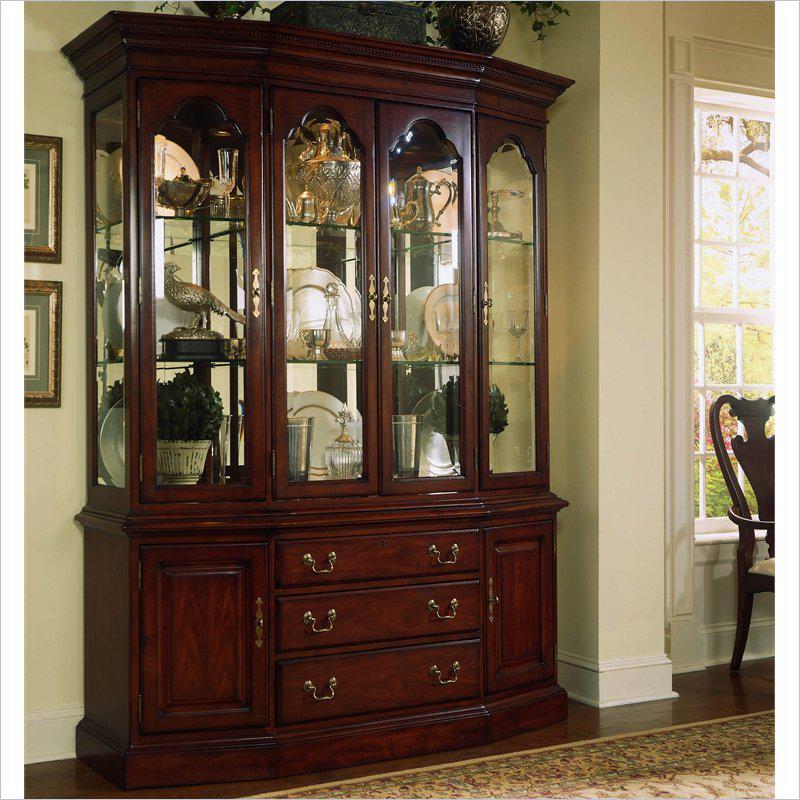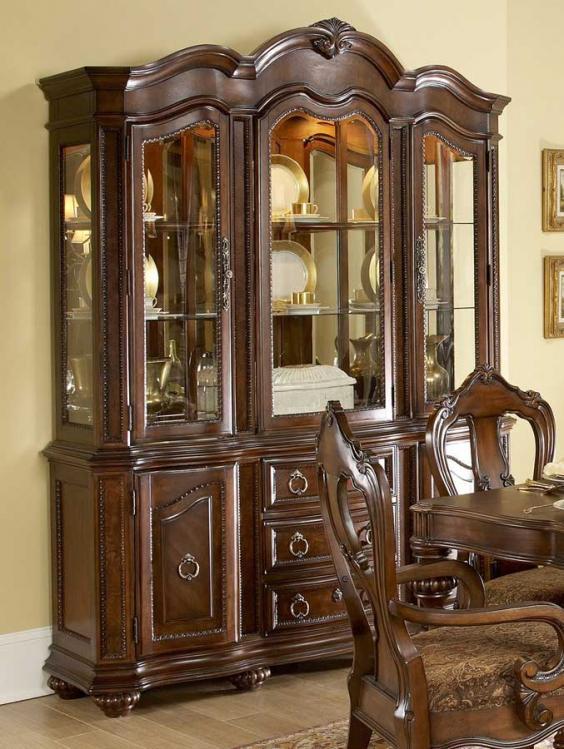The first image is the image on the left, the second image is the image on the right. Evaluate the accuracy of this statement regarding the images: "There is a brown chair with white seat.". Is it true? Answer yes or no. No. The first image is the image on the left, the second image is the image on the right. For the images displayed, is the sentence "Wooden china cabinets in both images are dark and ornate with curved details." factually correct? Answer yes or no. Yes. 